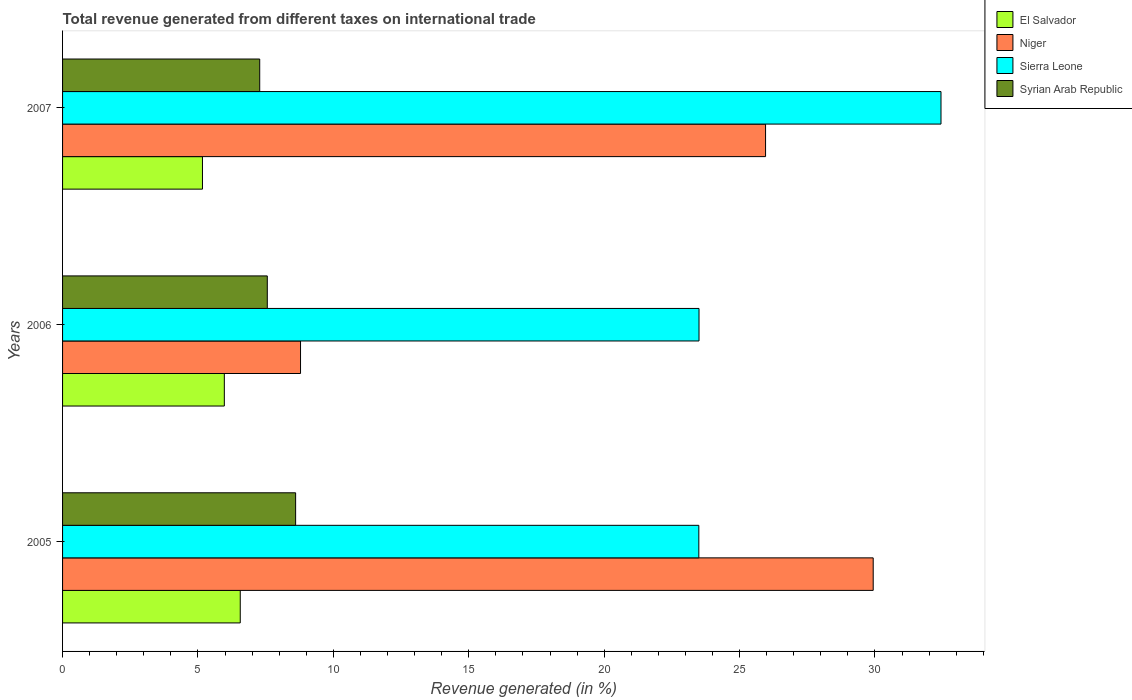How many different coloured bars are there?
Your response must be concise. 4. How many groups of bars are there?
Your answer should be compact. 3. Are the number of bars on each tick of the Y-axis equal?
Make the answer very short. Yes. What is the label of the 1st group of bars from the top?
Your response must be concise. 2007. In how many cases, is the number of bars for a given year not equal to the number of legend labels?
Provide a succinct answer. 0. What is the total revenue generated in Syrian Arab Republic in 2005?
Offer a very short reply. 8.61. Across all years, what is the maximum total revenue generated in El Salvador?
Give a very brief answer. 6.56. Across all years, what is the minimum total revenue generated in El Salvador?
Offer a very short reply. 5.17. In which year was the total revenue generated in El Salvador minimum?
Provide a succinct answer. 2007. What is the total total revenue generated in El Salvador in the graph?
Your response must be concise. 17.7. What is the difference between the total revenue generated in Sierra Leone in 2006 and that in 2007?
Provide a succinct answer. -8.94. What is the difference between the total revenue generated in Syrian Arab Republic in 2006 and the total revenue generated in Niger in 2005?
Make the answer very short. -22.37. What is the average total revenue generated in Niger per year?
Your answer should be compact. 21.56. In the year 2005, what is the difference between the total revenue generated in Niger and total revenue generated in Syrian Arab Republic?
Give a very brief answer. 21.33. What is the ratio of the total revenue generated in Syrian Arab Republic in 2005 to that in 2007?
Offer a terse response. 1.18. What is the difference between the highest and the second highest total revenue generated in El Salvador?
Provide a short and direct response. 0.59. What is the difference between the highest and the lowest total revenue generated in Niger?
Ensure brevity in your answer.  21.15. What does the 1st bar from the top in 2005 represents?
Make the answer very short. Syrian Arab Republic. What does the 2nd bar from the bottom in 2006 represents?
Keep it short and to the point. Niger. How many bars are there?
Offer a terse response. 12. Are all the bars in the graph horizontal?
Your response must be concise. Yes. How many years are there in the graph?
Give a very brief answer. 3. What is the difference between two consecutive major ticks on the X-axis?
Give a very brief answer. 5. Does the graph contain grids?
Offer a terse response. No. Where does the legend appear in the graph?
Give a very brief answer. Top right. What is the title of the graph?
Provide a succinct answer. Total revenue generated from different taxes on international trade. What is the label or title of the X-axis?
Ensure brevity in your answer.  Revenue generated (in %). What is the label or title of the Y-axis?
Provide a short and direct response. Years. What is the Revenue generated (in %) in El Salvador in 2005?
Keep it short and to the point. 6.56. What is the Revenue generated (in %) in Niger in 2005?
Your response must be concise. 29.93. What is the Revenue generated (in %) of Sierra Leone in 2005?
Make the answer very short. 23.5. What is the Revenue generated (in %) in Syrian Arab Republic in 2005?
Your response must be concise. 8.61. What is the Revenue generated (in %) in El Salvador in 2006?
Offer a very short reply. 5.97. What is the Revenue generated (in %) in Niger in 2006?
Ensure brevity in your answer.  8.79. What is the Revenue generated (in %) in Sierra Leone in 2006?
Your answer should be compact. 23.5. What is the Revenue generated (in %) of Syrian Arab Republic in 2006?
Keep it short and to the point. 7.56. What is the Revenue generated (in %) in El Salvador in 2007?
Ensure brevity in your answer.  5.17. What is the Revenue generated (in %) in Niger in 2007?
Your answer should be compact. 25.96. What is the Revenue generated (in %) of Sierra Leone in 2007?
Your response must be concise. 32.44. What is the Revenue generated (in %) of Syrian Arab Republic in 2007?
Ensure brevity in your answer.  7.28. Across all years, what is the maximum Revenue generated (in %) in El Salvador?
Your answer should be very brief. 6.56. Across all years, what is the maximum Revenue generated (in %) of Niger?
Provide a succinct answer. 29.93. Across all years, what is the maximum Revenue generated (in %) of Sierra Leone?
Keep it short and to the point. 32.44. Across all years, what is the maximum Revenue generated (in %) in Syrian Arab Republic?
Ensure brevity in your answer.  8.61. Across all years, what is the minimum Revenue generated (in %) of El Salvador?
Make the answer very short. 5.17. Across all years, what is the minimum Revenue generated (in %) in Niger?
Make the answer very short. 8.79. Across all years, what is the minimum Revenue generated (in %) of Sierra Leone?
Your answer should be very brief. 23.5. Across all years, what is the minimum Revenue generated (in %) in Syrian Arab Republic?
Give a very brief answer. 7.28. What is the total Revenue generated (in %) in El Salvador in the graph?
Offer a very short reply. 17.7. What is the total Revenue generated (in %) in Niger in the graph?
Your answer should be very brief. 64.68. What is the total Revenue generated (in %) of Sierra Leone in the graph?
Offer a terse response. 79.44. What is the total Revenue generated (in %) in Syrian Arab Republic in the graph?
Your answer should be very brief. 23.45. What is the difference between the Revenue generated (in %) of El Salvador in 2005 and that in 2006?
Provide a short and direct response. 0.59. What is the difference between the Revenue generated (in %) of Niger in 2005 and that in 2006?
Ensure brevity in your answer.  21.15. What is the difference between the Revenue generated (in %) in Sierra Leone in 2005 and that in 2006?
Offer a terse response. -0.01. What is the difference between the Revenue generated (in %) in Syrian Arab Republic in 2005 and that in 2006?
Your answer should be very brief. 1.05. What is the difference between the Revenue generated (in %) in El Salvador in 2005 and that in 2007?
Your response must be concise. 1.4. What is the difference between the Revenue generated (in %) in Niger in 2005 and that in 2007?
Provide a short and direct response. 3.97. What is the difference between the Revenue generated (in %) in Sierra Leone in 2005 and that in 2007?
Offer a terse response. -8.94. What is the difference between the Revenue generated (in %) of Syrian Arab Republic in 2005 and that in 2007?
Your answer should be compact. 1.33. What is the difference between the Revenue generated (in %) of El Salvador in 2006 and that in 2007?
Make the answer very short. 0.81. What is the difference between the Revenue generated (in %) in Niger in 2006 and that in 2007?
Your answer should be compact. -17.17. What is the difference between the Revenue generated (in %) in Sierra Leone in 2006 and that in 2007?
Provide a short and direct response. -8.94. What is the difference between the Revenue generated (in %) in Syrian Arab Republic in 2006 and that in 2007?
Offer a very short reply. 0.28. What is the difference between the Revenue generated (in %) of El Salvador in 2005 and the Revenue generated (in %) of Niger in 2006?
Give a very brief answer. -2.23. What is the difference between the Revenue generated (in %) of El Salvador in 2005 and the Revenue generated (in %) of Sierra Leone in 2006?
Your response must be concise. -16.94. What is the difference between the Revenue generated (in %) of El Salvador in 2005 and the Revenue generated (in %) of Syrian Arab Republic in 2006?
Provide a short and direct response. -1. What is the difference between the Revenue generated (in %) in Niger in 2005 and the Revenue generated (in %) in Sierra Leone in 2006?
Provide a short and direct response. 6.43. What is the difference between the Revenue generated (in %) in Niger in 2005 and the Revenue generated (in %) in Syrian Arab Republic in 2006?
Your answer should be compact. 22.37. What is the difference between the Revenue generated (in %) in Sierra Leone in 2005 and the Revenue generated (in %) in Syrian Arab Republic in 2006?
Make the answer very short. 15.94. What is the difference between the Revenue generated (in %) in El Salvador in 2005 and the Revenue generated (in %) in Niger in 2007?
Offer a terse response. -19.4. What is the difference between the Revenue generated (in %) of El Salvador in 2005 and the Revenue generated (in %) of Sierra Leone in 2007?
Give a very brief answer. -25.88. What is the difference between the Revenue generated (in %) in El Salvador in 2005 and the Revenue generated (in %) in Syrian Arab Republic in 2007?
Make the answer very short. -0.72. What is the difference between the Revenue generated (in %) in Niger in 2005 and the Revenue generated (in %) in Sierra Leone in 2007?
Offer a very short reply. -2.5. What is the difference between the Revenue generated (in %) in Niger in 2005 and the Revenue generated (in %) in Syrian Arab Republic in 2007?
Offer a very short reply. 22.65. What is the difference between the Revenue generated (in %) of Sierra Leone in 2005 and the Revenue generated (in %) of Syrian Arab Republic in 2007?
Offer a terse response. 16.22. What is the difference between the Revenue generated (in %) in El Salvador in 2006 and the Revenue generated (in %) in Niger in 2007?
Make the answer very short. -19.99. What is the difference between the Revenue generated (in %) of El Salvador in 2006 and the Revenue generated (in %) of Sierra Leone in 2007?
Keep it short and to the point. -26.46. What is the difference between the Revenue generated (in %) in El Salvador in 2006 and the Revenue generated (in %) in Syrian Arab Republic in 2007?
Your answer should be very brief. -1.31. What is the difference between the Revenue generated (in %) of Niger in 2006 and the Revenue generated (in %) of Sierra Leone in 2007?
Ensure brevity in your answer.  -23.65. What is the difference between the Revenue generated (in %) in Niger in 2006 and the Revenue generated (in %) in Syrian Arab Republic in 2007?
Your answer should be very brief. 1.51. What is the difference between the Revenue generated (in %) in Sierra Leone in 2006 and the Revenue generated (in %) in Syrian Arab Republic in 2007?
Offer a terse response. 16.22. What is the average Revenue generated (in %) in El Salvador per year?
Ensure brevity in your answer.  5.9. What is the average Revenue generated (in %) of Niger per year?
Your answer should be compact. 21.56. What is the average Revenue generated (in %) in Sierra Leone per year?
Make the answer very short. 26.48. What is the average Revenue generated (in %) of Syrian Arab Republic per year?
Provide a short and direct response. 7.82. In the year 2005, what is the difference between the Revenue generated (in %) of El Salvador and Revenue generated (in %) of Niger?
Give a very brief answer. -23.37. In the year 2005, what is the difference between the Revenue generated (in %) in El Salvador and Revenue generated (in %) in Sierra Leone?
Ensure brevity in your answer.  -16.93. In the year 2005, what is the difference between the Revenue generated (in %) of El Salvador and Revenue generated (in %) of Syrian Arab Republic?
Your answer should be very brief. -2.04. In the year 2005, what is the difference between the Revenue generated (in %) of Niger and Revenue generated (in %) of Sierra Leone?
Provide a succinct answer. 6.44. In the year 2005, what is the difference between the Revenue generated (in %) of Niger and Revenue generated (in %) of Syrian Arab Republic?
Offer a terse response. 21.33. In the year 2005, what is the difference between the Revenue generated (in %) of Sierra Leone and Revenue generated (in %) of Syrian Arab Republic?
Provide a short and direct response. 14.89. In the year 2006, what is the difference between the Revenue generated (in %) in El Salvador and Revenue generated (in %) in Niger?
Offer a terse response. -2.81. In the year 2006, what is the difference between the Revenue generated (in %) of El Salvador and Revenue generated (in %) of Sierra Leone?
Your answer should be compact. -17.53. In the year 2006, what is the difference between the Revenue generated (in %) in El Salvador and Revenue generated (in %) in Syrian Arab Republic?
Offer a very short reply. -1.59. In the year 2006, what is the difference between the Revenue generated (in %) in Niger and Revenue generated (in %) in Sierra Leone?
Offer a very short reply. -14.72. In the year 2006, what is the difference between the Revenue generated (in %) of Niger and Revenue generated (in %) of Syrian Arab Republic?
Your answer should be compact. 1.23. In the year 2006, what is the difference between the Revenue generated (in %) of Sierra Leone and Revenue generated (in %) of Syrian Arab Republic?
Give a very brief answer. 15.94. In the year 2007, what is the difference between the Revenue generated (in %) of El Salvador and Revenue generated (in %) of Niger?
Make the answer very short. -20.79. In the year 2007, what is the difference between the Revenue generated (in %) in El Salvador and Revenue generated (in %) in Sierra Leone?
Provide a succinct answer. -27.27. In the year 2007, what is the difference between the Revenue generated (in %) in El Salvador and Revenue generated (in %) in Syrian Arab Republic?
Provide a succinct answer. -2.11. In the year 2007, what is the difference between the Revenue generated (in %) in Niger and Revenue generated (in %) in Sierra Leone?
Ensure brevity in your answer.  -6.48. In the year 2007, what is the difference between the Revenue generated (in %) of Niger and Revenue generated (in %) of Syrian Arab Republic?
Ensure brevity in your answer.  18.68. In the year 2007, what is the difference between the Revenue generated (in %) in Sierra Leone and Revenue generated (in %) in Syrian Arab Republic?
Offer a terse response. 25.16. What is the ratio of the Revenue generated (in %) of El Salvador in 2005 to that in 2006?
Your answer should be compact. 1.1. What is the ratio of the Revenue generated (in %) of Niger in 2005 to that in 2006?
Ensure brevity in your answer.  3.41. What is the ratio of the Revenue generated (in %) of Sierra Leone in 2005 to that in 2006?
Your response must be concise. 1. What is the ratio of the Revenue generated (in %) in Syrian Arab Republic in 2005 to that in 2006?
Provide a succinct answer. 1.14. What is the ratio of the Revenue generated (in %) of El Salvador in 2005 to that in 2007?
Your answer should be very brief. 1.27. What is the ratio of the Revenue generated (in %) in Niger in 2005 to that in 2007?
Ensure brevity in your answer.  1.15. What is the ratio of the Revenue generated (in %) in Sierra Leone in 2005 to that in 2007?
Provide a short and direct response. 0.72. What is the ratio of the Revenue generated (in %) in Syrian Arab Republic in 2005 to that in 2007?
Offer a terse response. 1.18. What is the ratio of the Revenue generated (in %) in El Salvador in 2006 to that in 2007?
Give a very brief answer. 1.16. What is the ratio of the Revenue generated (in %) in Niger in 2006 to that in 2007?
Offer a very short reply. 0.34. What is the ratio of the Revenue generated (in %) in Sierra Leone in 2006 to that in 2007?
Give a very brief answer. 0.72. What is the ratio of the Revenue generated (in %) in Syrian Arab Republic in 2006 to that in 2007?
Make the answer very short. 1.04. What is the difference between the highest and the second highest Revenue generated (in %) of El Salvador?
Your response must be concise. 0.59. What is the difference between the highest and the second highest Revenue generated (in %) in Niger?
Provide a short and direct response. 3.97. What is the difference between the highest and the second highest Revenue generated (in %) of Sierra Leone?
Give a very brief answer. 8.94. What is the difference between the highest and the second highest Revenue generated (in %) of Syrian Arab Republic?
Give a very brief answer. 1.05. What is the difference between the highest and the lowest Revenue generated (in %) of El Salvador?
Keep it short and to the point. 1.4. What is the difference between the highest and the lowest Revenue generated (in %) of Niger?
Provide a short and direct response. 21.15. What is the difference between the highest and the lowest Revenue generated (in %) in Sierra Leone?
Offer a very short reply. 8.94. What is the difference between the highest and the lowest Revenue generated (in %) of Syrian Arab Republic?
Make the answer very short. 1.33. 